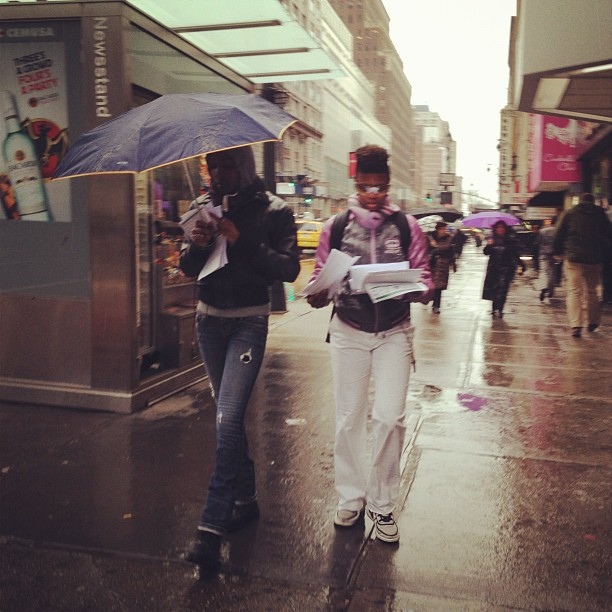<image>What kind of sign is the boy holding? The boy is not holding a sign in the image. It could be a paper or flyer. What kind of sign is the boy holding? I am not sure what kind of sign the boy is holding. It can be seen as a flyer, paperwork, or just paper. 